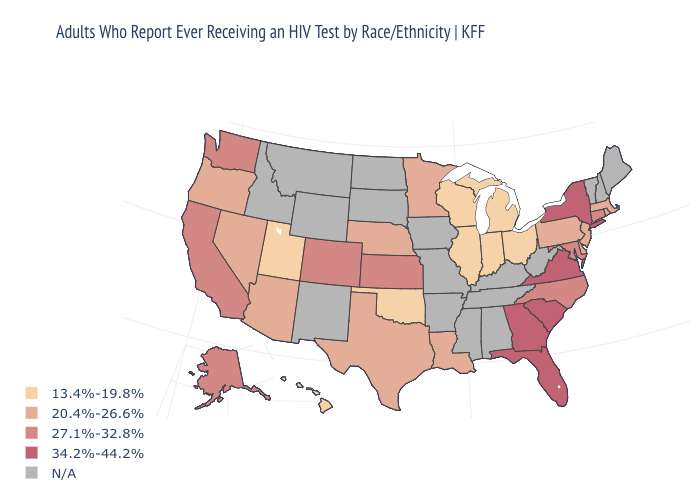How many symbols are there in the legend?
Short answer required. 5. Is the legend a continuous bar?
Concise answer only. No. Which states hav the highest value in the South?
Answer briefly. Florida, Georgia, South Carolina, Virginia. Which states have the lowest value in the USA?
Quick response, please. Hawaii, Illinois, Indiana, Michigan, Ohio, Oklahoma, Utah, Wisconsin. What is the value of California?
Keep it brief. 27.1%-32.8%. What is the lowest value in states that border New York?
Write a very short answer. 20.4%-26.6%. Name the states that have a value in the range 20.4%-26.6%?
Keep it brief. Arizona, Delaware, Louisiana, Massachusetts, Minnesota, Nebraska, Nevada, New Jersey, Oregon, Pennsylvania, Rhode Island, Texas. Does the map have missing data?
Quick response, please. Yes. Name the states that have a value in the range 20.4%-26.6%?
Quick response, please. Arizona, Delaware, Louisiana, Massachusetts, Minnesota, Nebraska, Nevada, New Jersey, Oregon, Pennsylvania, Rhode Island, Texas. Does the first symbol in the legend represent the smallest category?
Quick response, please. Yes. What is the highest value in the USA?
Quick response, please. 34.2%-44.2%. Does the first symbol in the legend represent the smallest category?
Give a very brief answer. Yes. Is the legend a continuous bar?
Give a very brief answer. No. What is the value of Georgia?
Quick response, please. 34.2%-44.2%. Does Virginia have the highest value in the USA?
Give a very brief answer. Yes. 